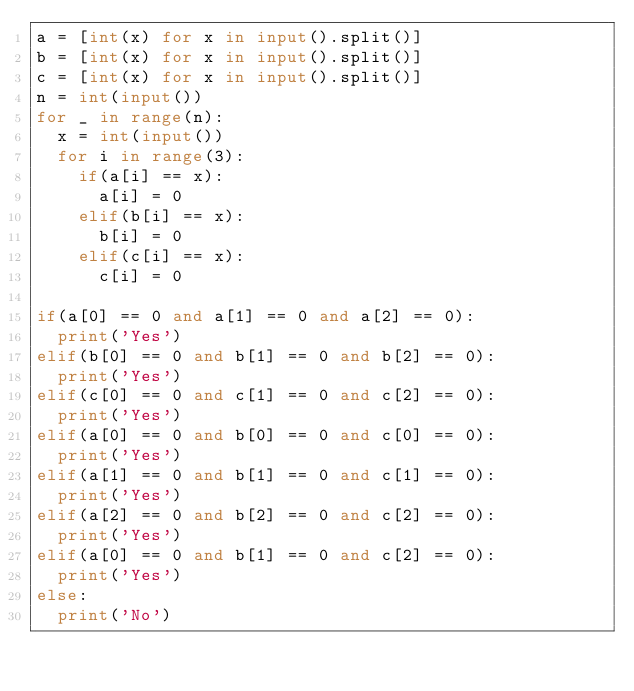Convert code to text. <code><loc_0><loc_0><loc_500><loc_500><_Python_>a = [int(x) for x in input().split()]
b = [int(x) for x in input().split()]
c = [int(x) for x in input().split()]
n = int(input())
for _ in range(n):
  x = int(input())
  for i in range(3):
    if(a[i] == x):
      a[i] = 0
    elif(b[i] == x):
      b[i] = 0
    elif(c[i] == x):
      c[i] = 0

if(a[0] == 0 and a[1] == 0 and a[2] == 0):
  print('Yes')
elif(b[0] == 0 and b[1] == 0 and b[2] == 0):
  print('Yes')
elif(c[0] == 0 and c[1] == 0 and c[2] == 0):
  print('Yes')
elif(a[0] == 0 and b[0] == 0 and c[0] == 0):
  print('Yes')
elif(a[1] == 0 and b[1] == 0 and c[1] == 0):
  print('Yes')
elif(a[2] == 0 and b[2] == 0 and c[2] == 0):
  print('Yes')
elif(a[0] == 0 and b[1] == 0 and c[2] == 0):
  print('Yes')
else:
  print('No')</code> 